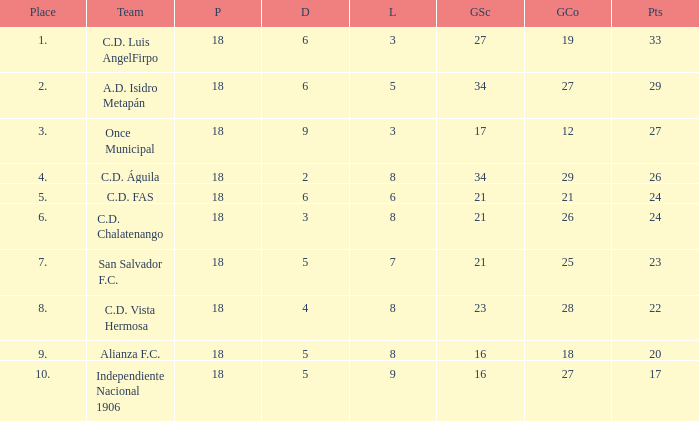What were the goal conceded that had a lost greater than 8 and more than 17 points? None. 